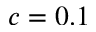Convert formula to latex. <formula><loc_0><loc_0><loc_500><loc_500>c = 0 . 1</formula> 